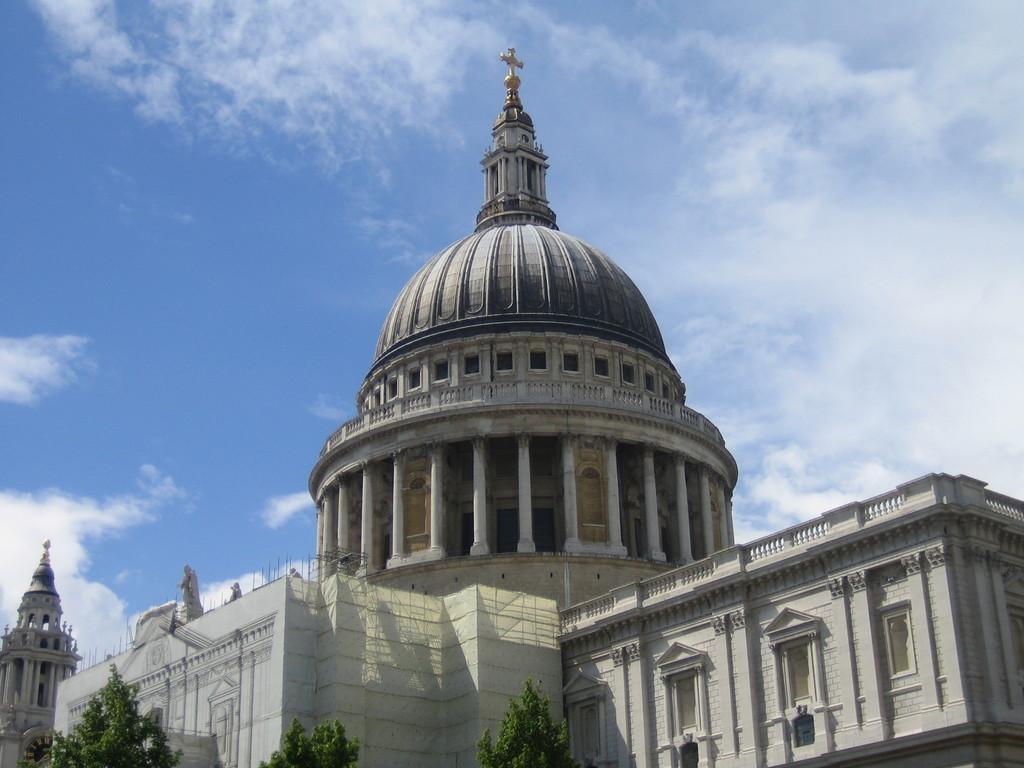Describe this image in one or two sentences. In this image, I can see a building with the pillars and windows. It looks like a holy cross symbol, which is at the top of a building. At the bottom of the image, I can see the trees. These are the clouds in the sky. 